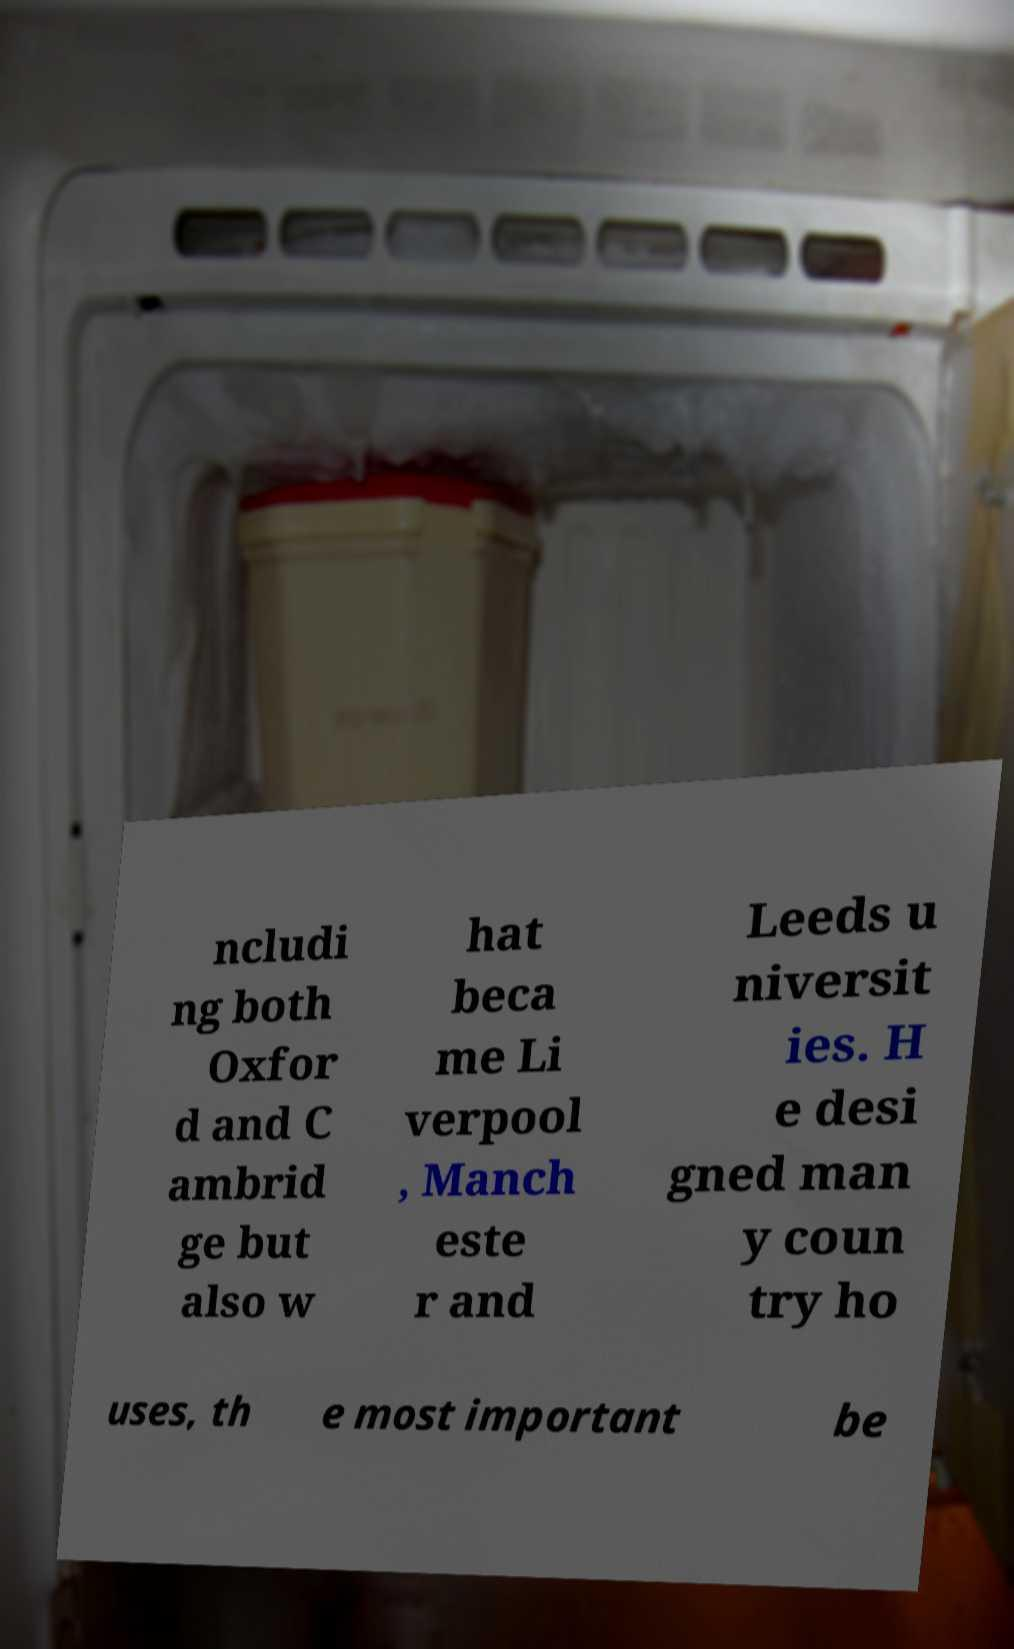Please identify and transcribe the text found in this image. ncludi ng both Oxfor d and C ambrid ge but also w hat beca me Li verpool , Manch este r and Leeds u niversit ies. H e desi gned man y coun try ho uses, th e most important be 